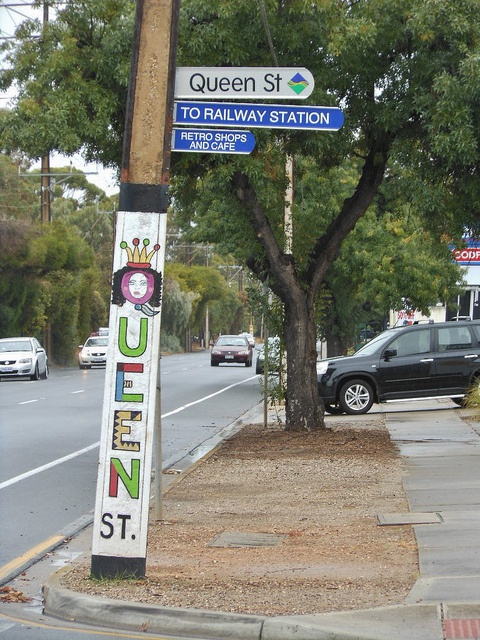Describe the objects in this image and their specific colors. I can see car in gray, black, and darkgray tones, car in gray, white, darkgray, and lightgray tones, car in gray, lightgray, black, and darkgray tones, car in gray, white, darkgray, and black tones, and car in gray, darkgray, lightgray, and black tones in this image. 